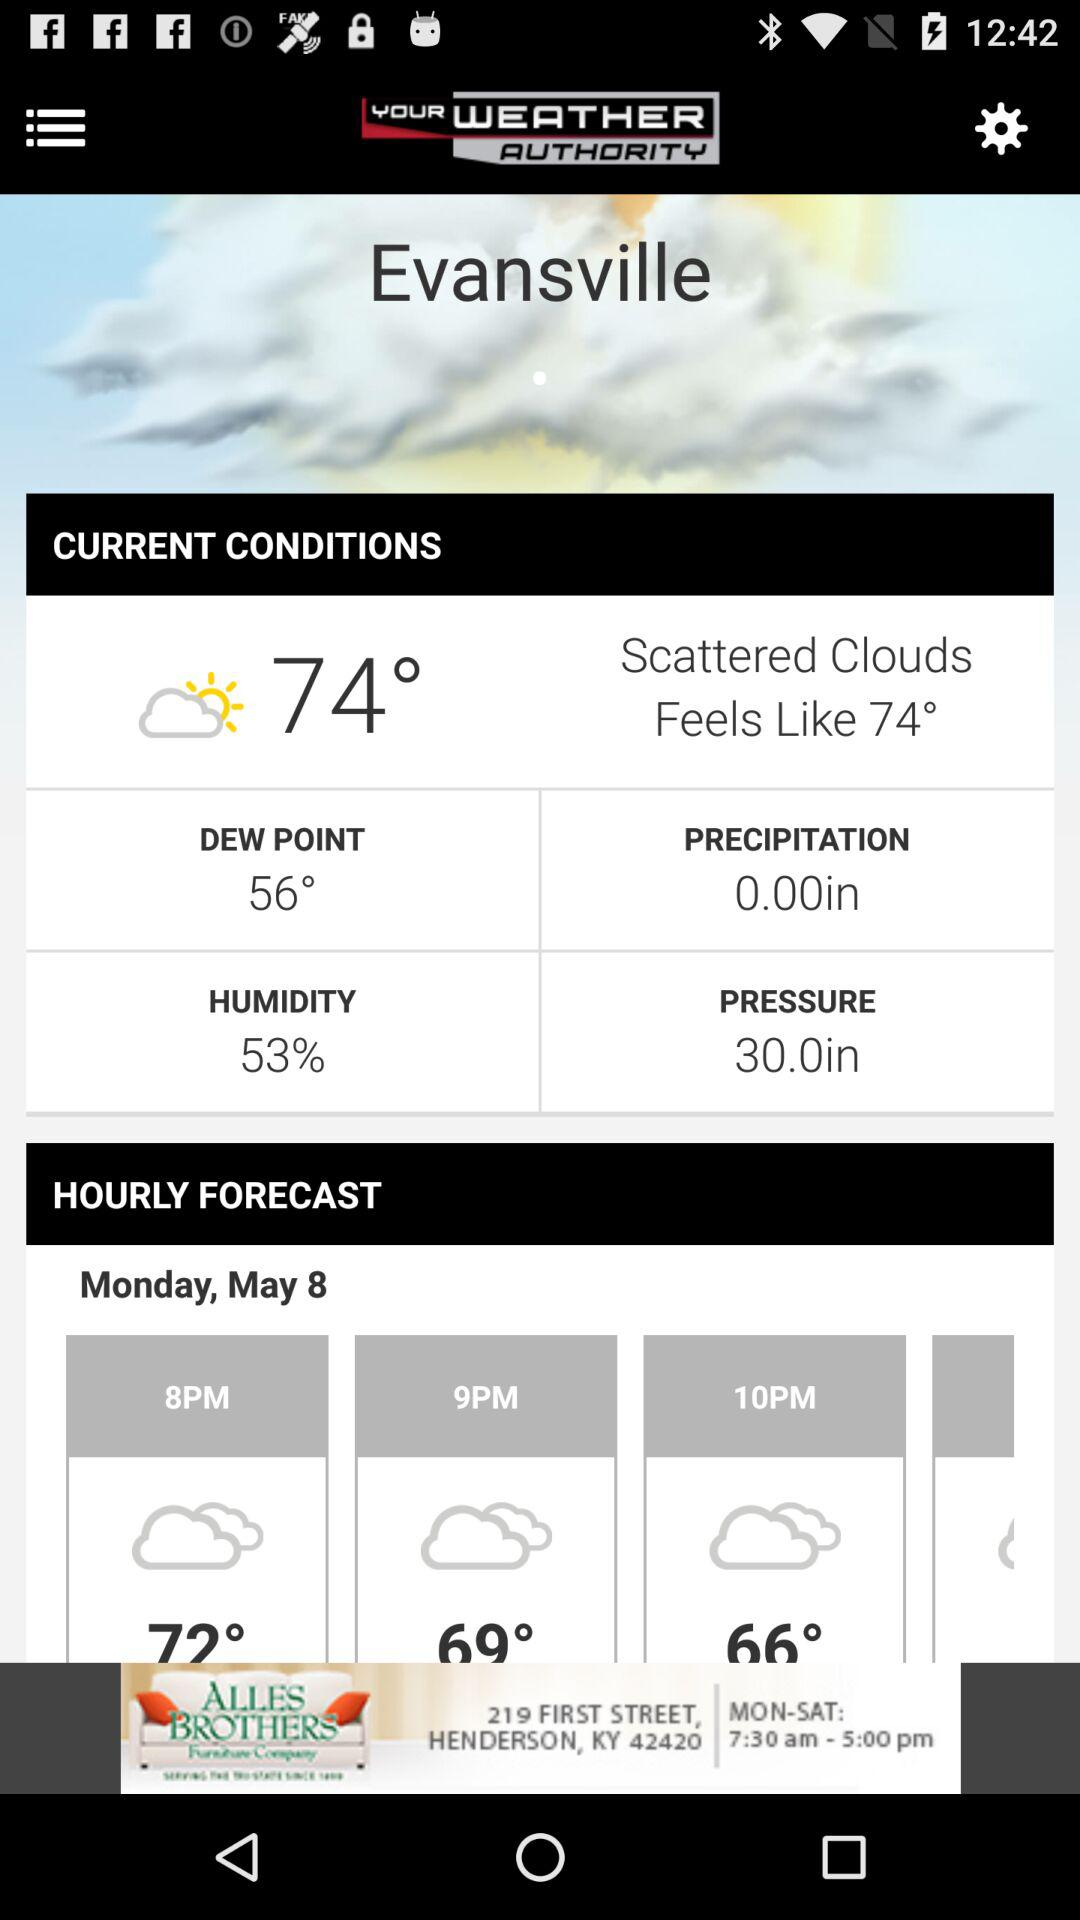What is the current dew point? The current dew point is 56 degrees. 